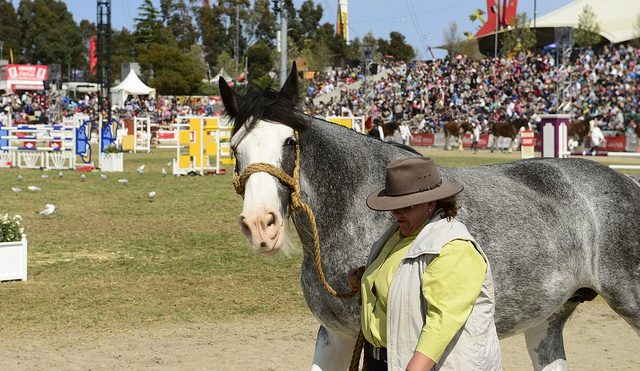Describe the objects in this image and their specific colors. I can see horse in black, gray, and darkgray tones, people in black, gray, and darkgray tones, people in black, khaki, lightgray, and gray tones, horse in black, darkgray, maroon, and gray tones, and horse in black, darkgray, lightgray, and gray tones in this image. 